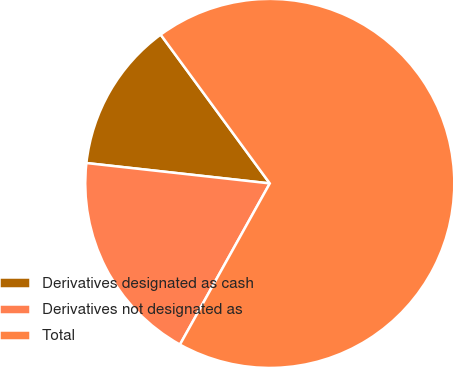Convert chart. <chart><loc_0><loc_0><loc_500><loc_500><pie_chart><fcel>Derivatives designated as cash<fcel>Derivatives not designated as<fcel>Total<nl><fcel>13.17%<fcel>18.67%<fcel>68.17%<nl></chart> 